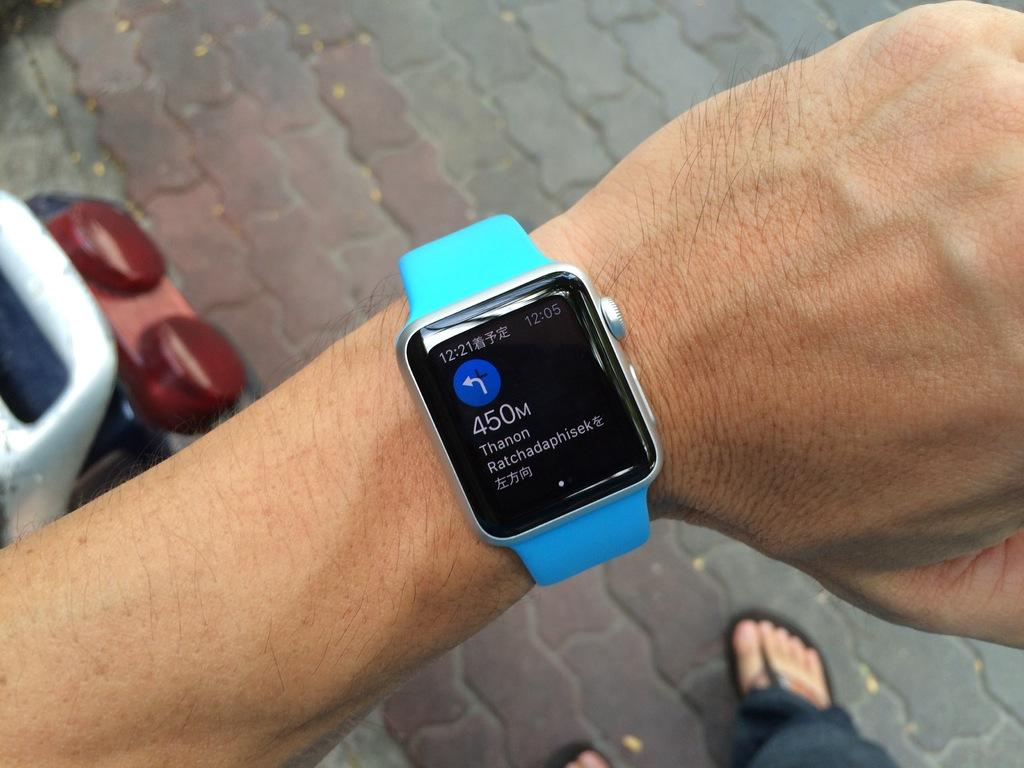<image>
Give a short and clear explanation of the subsequent image. A blue and black watch displays "450M Thanon Ratchadaphisek". 